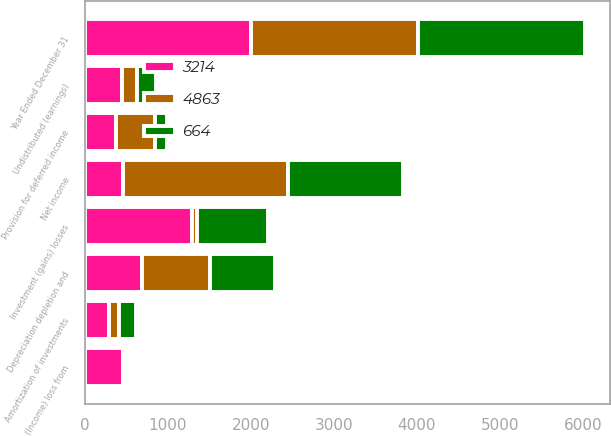<chart> <loc_0><loc_0><loc_500><loc_500><stacked_bar_chart><ecel><fcel>Year Ended December 31<fcel>Net income<fcel>(Income) loss from<fcel>Investment (gains) losses<fcel>Undistributed (earnings)<fcel>Amortization of investments<fcel>Depreciation depletion and<fcel>Provision for deferred income<nl><fcel>4863<fcel>2010<fcel>1987<fcel>20<fcel>56<fcel>184<fcel>118<fcel>816<fcel>471<nl><fcel>664<fcel>2009<fcel>1383<fcel>2<fcel>853<fcel>220<fcel>199<fcel>784<fcel>139<nl><fcel>3214<fcel>2008<fcel>461<fcel>461<fcel>1294<fcel>451<fcel>299<fcel>692<fcel>378<nl></chart> 